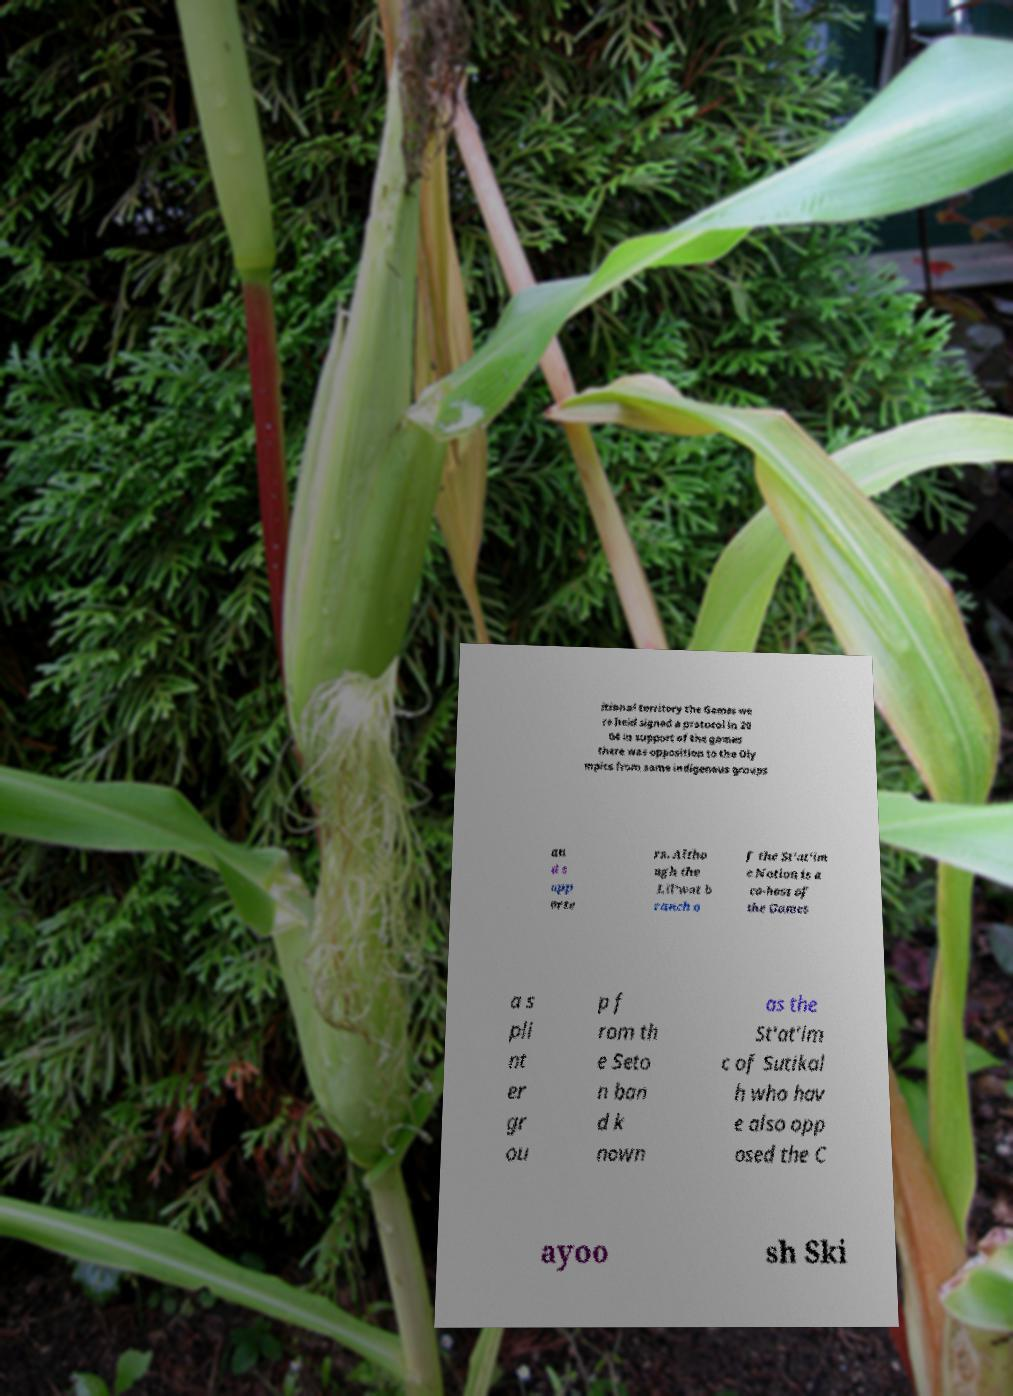For documentation purposes, I need the text within this image transcribed. Could you provide that? itional territory the Games we re held signed a protocol in 20 04 in support of the games there was opposition to the Oly mpics from some indigenous groups an d s upp orte rs. Altho ugh the Lil'wat b ranch o f the St'at'im c Nation is a co-host of the Games a s pli nt er gr ou p f rom th e Seto n ban d k nown as the St'at'im c of Sutikal h who hav e also opp osed the C ayoo sh Ski 